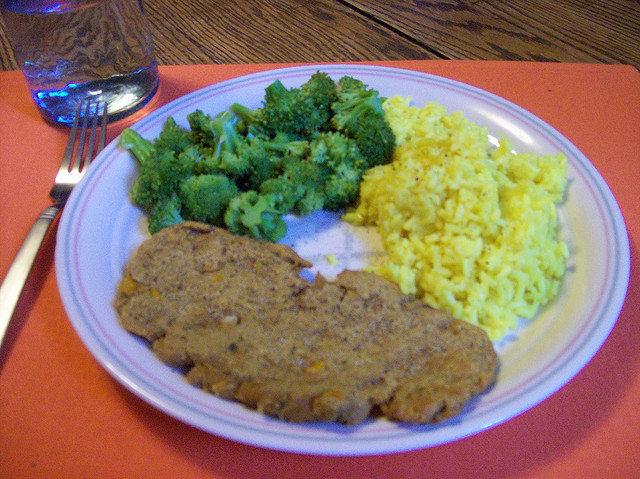Can you describe the nutritional value of this meal? Certainly! The broccoli is a great source of dietary fiber, vitamins C and K, and provides antioxidants. The yellow rice, likely seasoned with turmeric, contributes carbohydrates and some phytonutrients. The meatloaf is rich in protein and essential nutrients, such as iron and B vitamins, though its fat content may vary based on the recipe. 